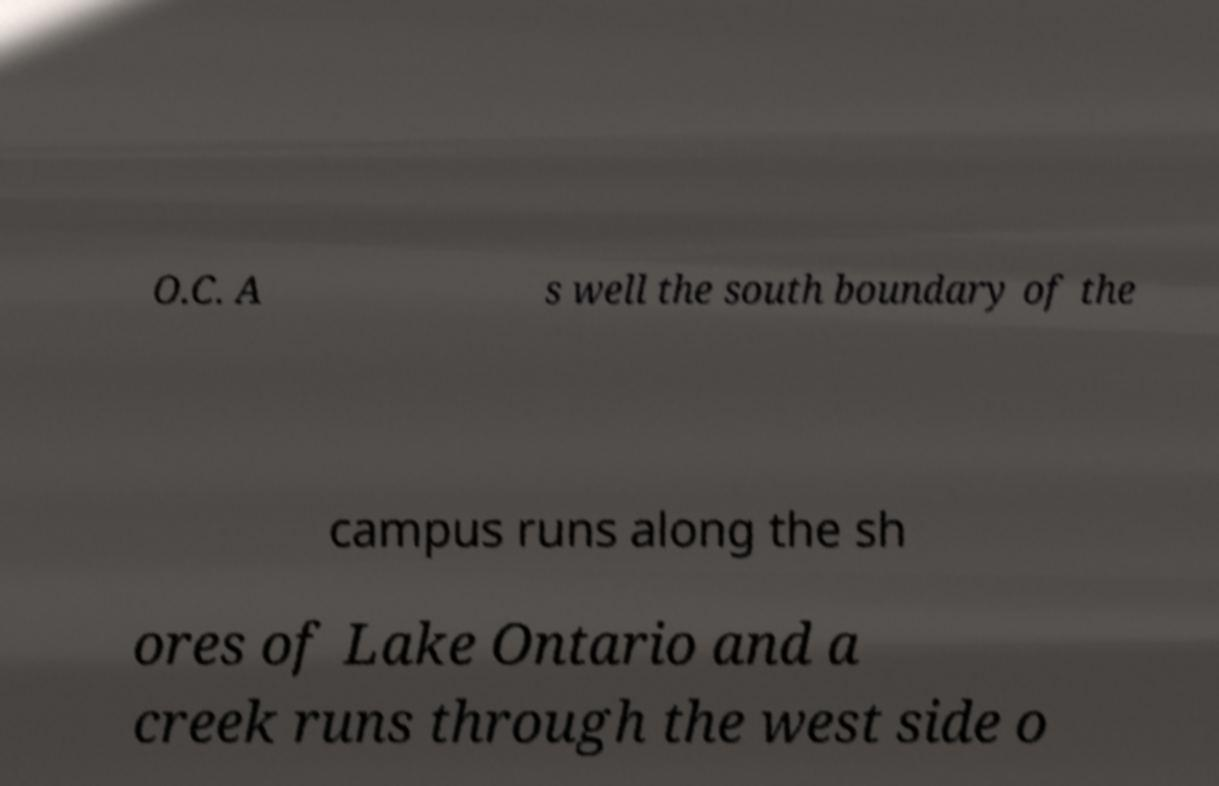There's text embedded in this image that I need extracted. Can you transcribe it verbatim? O.C. A s well the south boundary of the campus runs along the sh ores of Lake Ontario and a creek runs through the west side o 